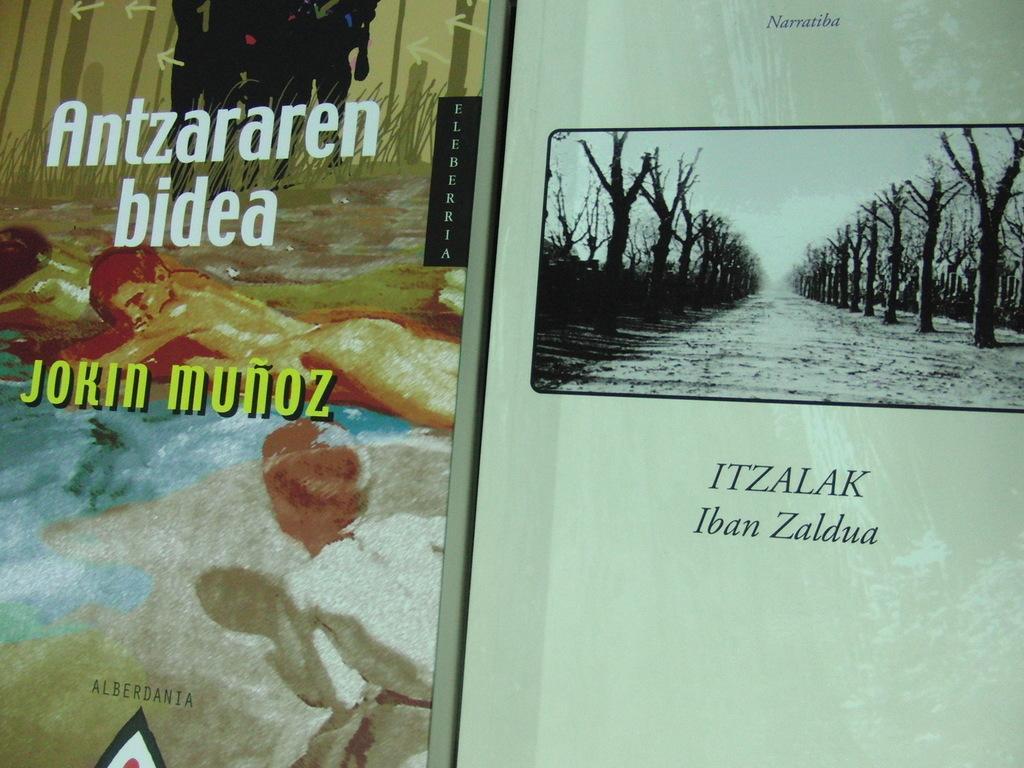How would you summarize this image in a sentence or two? This image consists of books. On the right, we can see many trees. On the left, there are two persons. And there is text on the books. 